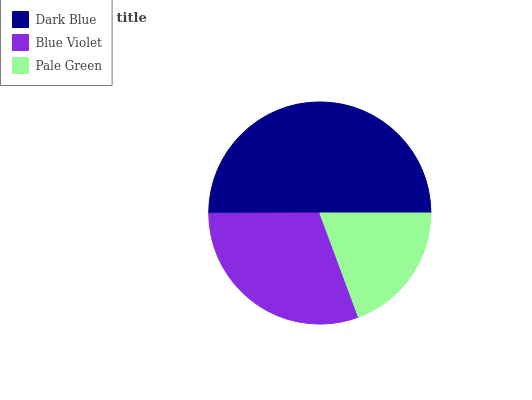Is Pale Green the minimum?
Answer yes or no. Yes. Is Dark Blue the maximum?
Answer yes or no. Yes. Is Blue Violet the minimum?
Answer yes or no. No. Is Blue Violet the maximum?
Answer yes or no. No. Is Dark Blue greater than Blue Violet?
Answer yes or no. Yes. Is Blue Violet less than Dark Blue?
Answer yes or no. Yes. Is Blue Violet greater than Dark Blue?
Answer yes or no. No. Is Dark Blue less than Blue Violet?
Answer yes or no. No. Is Blue Violet the high median?
Answer yes or no. Yes. Is Blue Violet the low median?
Answer yes or no. Yes. Is Pale Green the high median?
Answer yes or no. No. Is Pale Green the low median?
Answer yes or no. No. 